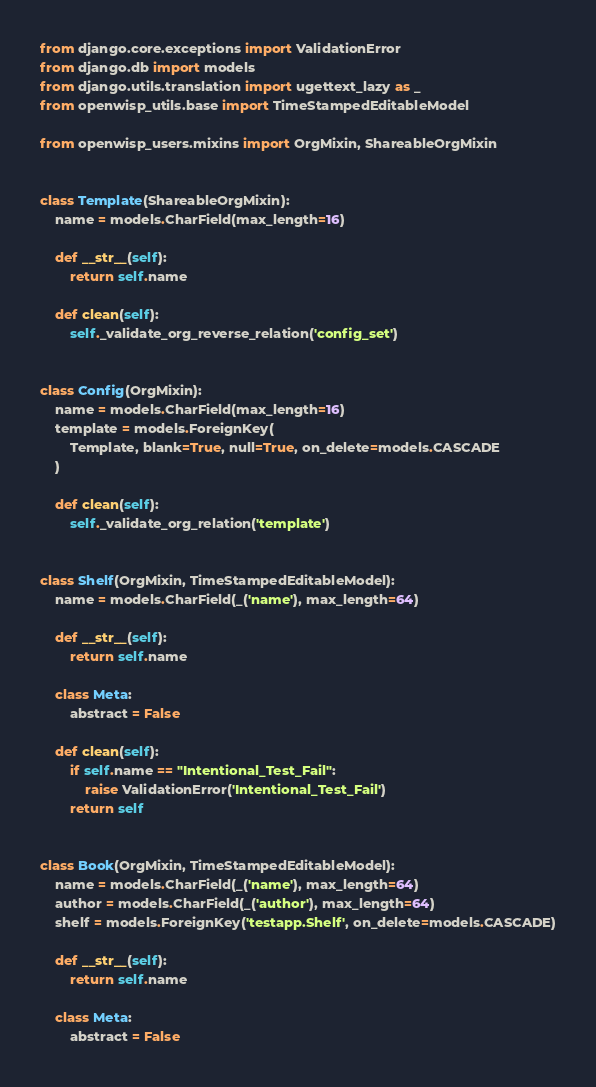Convert code to text. <code><loc_0><loc_0><loc_500><loc_500><_Python_>from django.core.exceptions import ValidationError
from django.db import models
from django.utils.translation import ugettext_lazy as _
from openwisp_utils.base import TimeStampedEditableModel

from openwisp_users.mixins import OrgMixin, ShareableOrgMixin


class Template(ShareableOrgMixin):
    name = models.CharField(max_length=16)

    def __str__(self):
        return self.name

    def clean(self):
        self._validate_org_reverse_relation('config_set')


class Config(OrgMixin):
    name = models.CharField(max_length=16)
    template = models.ForeignKey(
        Template, blank=True, null=True, on_delete=models.CASCADE
    )

    def clean(self):
        self._validate_org_relation('template')


class Shelf(OrgMixin, TimeStampedEditableModel):
    name = models.CharField(_('name'), max_length=64)

    def __str__(self):
        return self.name

    class Meta:
        abstract = False

    def clean(self):
        if self.name == "Intentional_Test_Fail":
            raise ValidationError('Intentional_Test_Fail')
        return self


class Book(OrgMixin, TimeStampedEditableModel):
    name = models.CharField(_('name'), max_length=64)
    author = models.CharField(_('author'), max_length=64)
    shelf = models.ForeignKey('testapp.Shelf', on_delete=models.CASCADE)

    def __str__(self):
        return self.name

    class Meta:
        abstract = False
</code> 